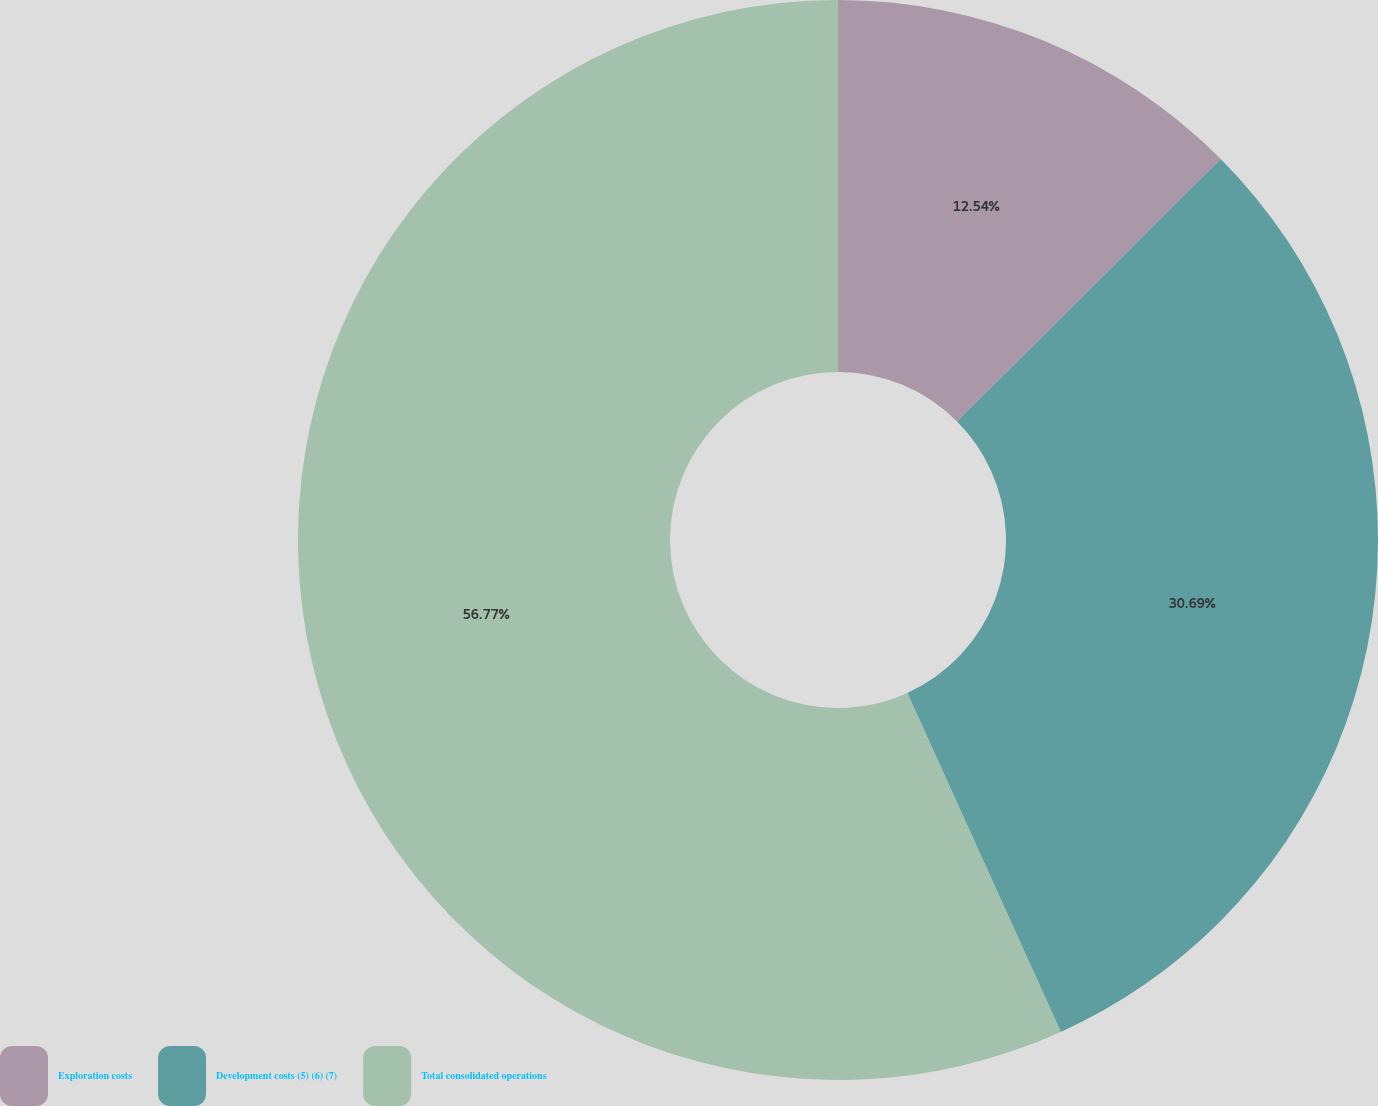Convert chart. <chart><loc_0><loc_0><loc_500><loc_500><pie_chart><fcel>Exploration costs<fcel>Development costs (5) (6) (7)<fcel>Total consolidated operations<nl><fcel>12.54%<fcel>30.69%<fcel>56.77%<nl></chart> 